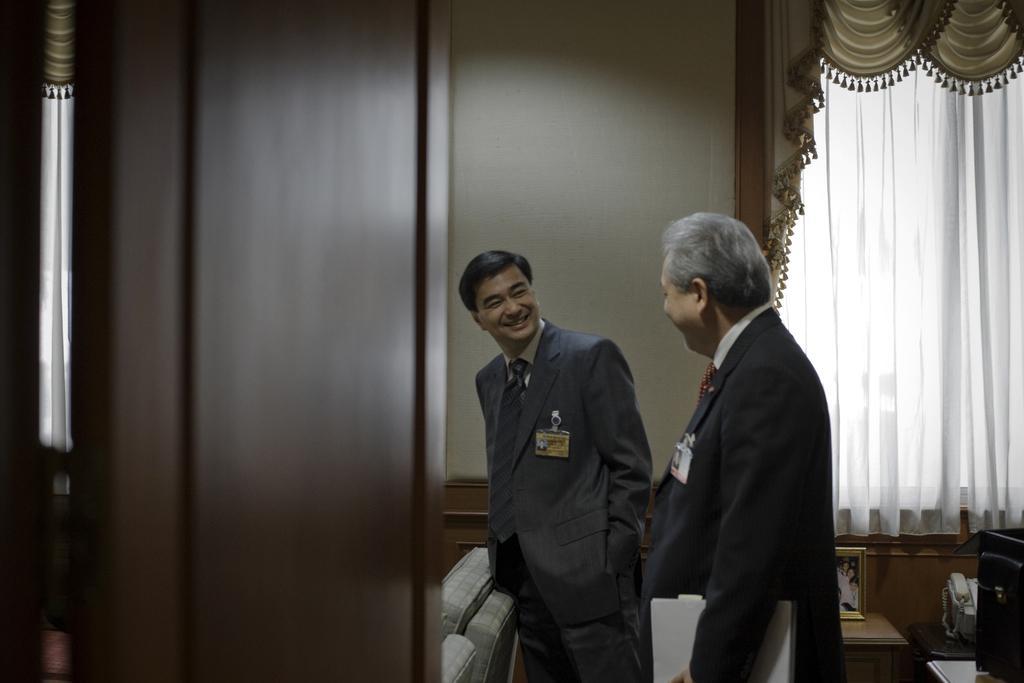In one or two sentences, can you explain what this image depicts? There are two men standing and smiling and this man holding books. We can see door, pole and chairs. In the background we can see telephone, frame and object on tables, wall and curtains. 